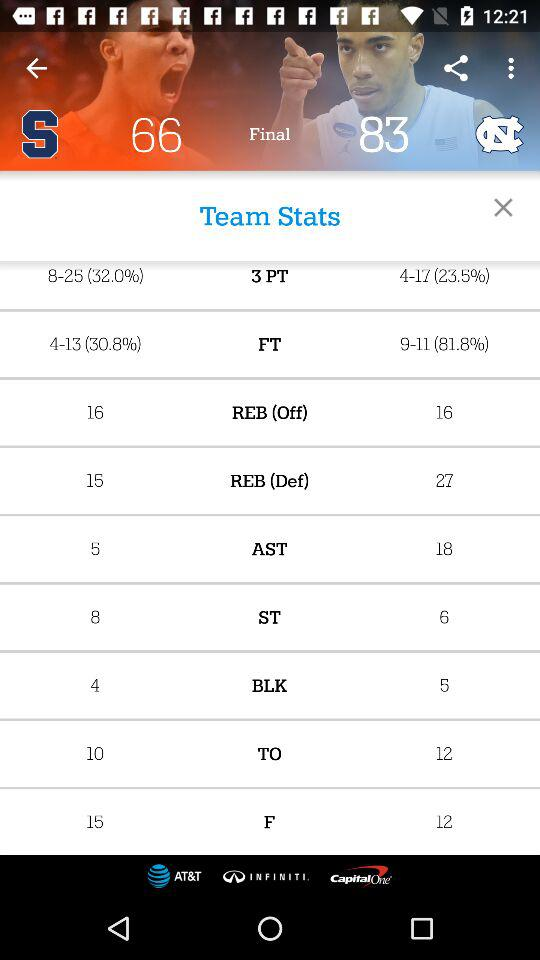How many assists has the North Carolina basketball team accumulated? The North Carolina basketball team has accumulated 18 assists. 